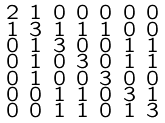<formula> <loc_0><loc_0><loc_500><loc_500>\begin{smallmatrix} 2 & 1 & 0 & 0 & 0 & 0 & 0 \\ 1 & 3 & 1 & 1 & 1 & 0 & 0 \\ 0 & 1 & 3 & 0 & 0 & 1 & 1 \\ 0 & 1 & 0 & 3 & 0 & 1 & 1 \\ 0 & 1 & 0 & 0 & 3 & 0 & 0 \\ 0 & 0 & 1 & 1 & 0 & 3 & 1 \\ 0 & 0 & 1 & 1 & 0 & 1 & 3 \end{smallmatrix}</formula> 